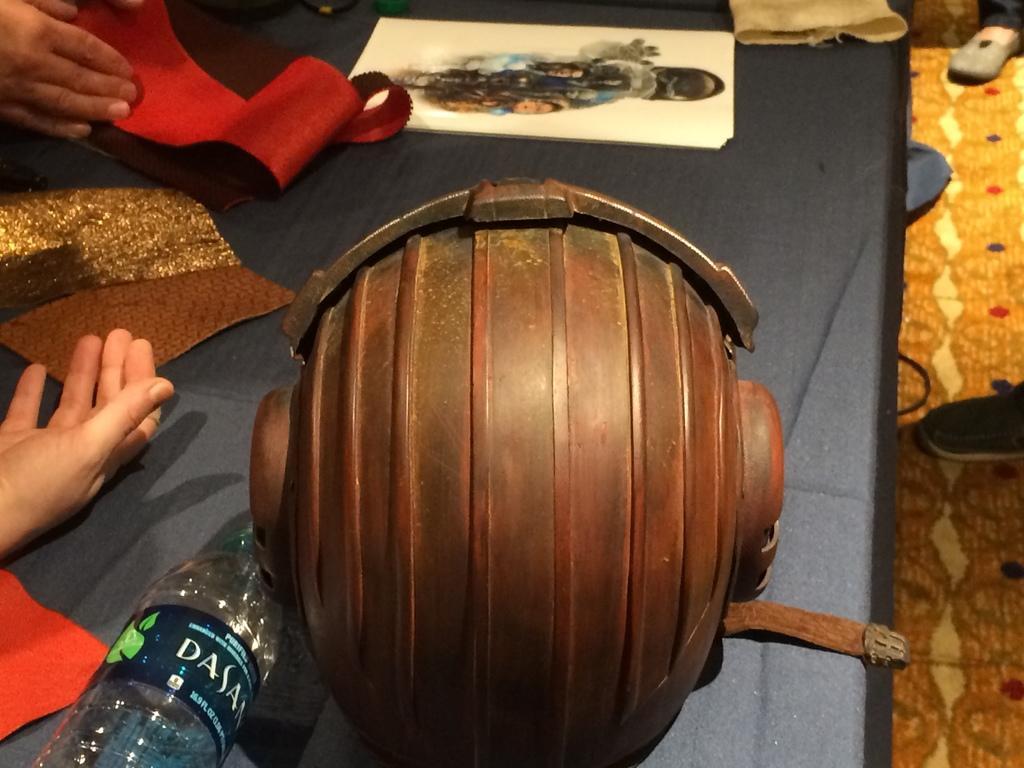How would you summarize this image in a sentence or two? In the middle of the image there is a table, On the table there is a paper and there is a helmet. Bottom left side of the image there is a water bottle. Top left side of the image there is a hand. Top right side of the image also there is a leg. 